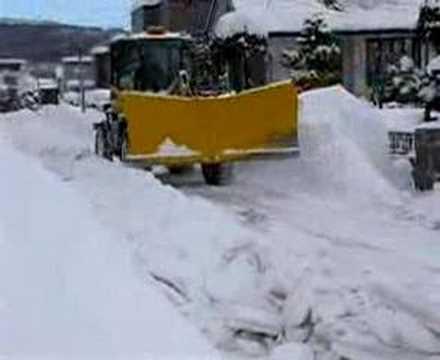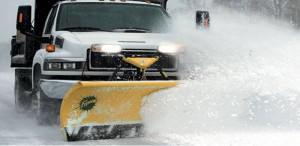The first image is the image on the left, the second image is the image on the right. Examine the images to the left and right. Is the description "All of the plows in the snow are yellow." accurate? Answer yes or no. Yes. The first image is the image on the left, the second image is the image on the right. Evaluate the accuracy of this statement regarding the images: "A truck with yellow bulldozer panel is pushing a pile of snow.". Is it true? Answer yes or no. Yes. 